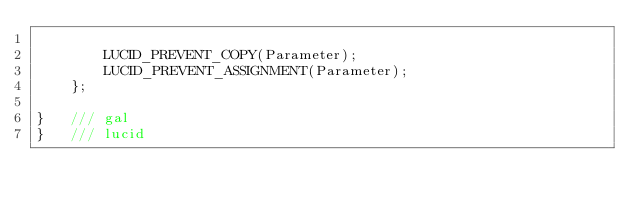<code> <loc_0><loc_0><loc_500><loc_500><_C_>
		LUCID_PREVENT_COPY(Parameter);
		LUCID_PREVENT_ASSIGNMENT(Parameter);
	};

}	///	gal
}	///	lucid
</code> 